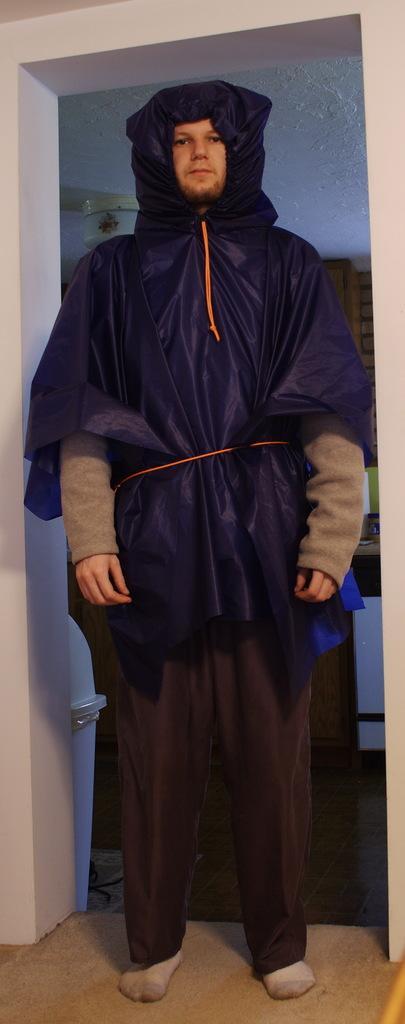Can you describe this image briefly? In this picture we can see a man standing in the front wearing a black raincoat and giving a pose to the camera. Behind we can see the white arch wall. 